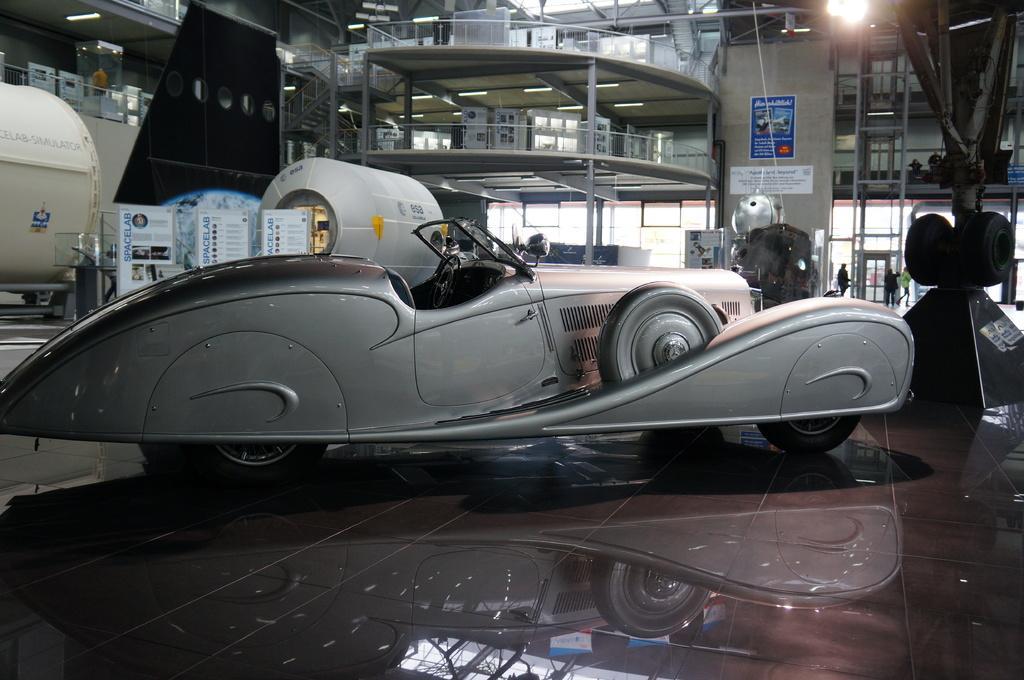In one or two sentences, can you explain what this image depicts? In this image there is a vehicle in the middle. In the background there is a two stair building. On the left side there are machines. In between the machines there are banners. At the top there is the light. There are boards on the floors. In the middle there is an object. On the right side there are wheels. Beside the wheels it looks like a ladder. This image is taken inside the hall. 